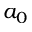Convert formula to latex. <formula><loc_0><loc_0><loc_500><loc_500>a _ { 0 }</formula> 